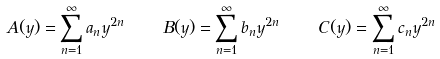<formula> <loc_0><loc_0><loc_500><loc_500>A ( y ) = \sum _ { n = 1 } ^ { \infty } a _ { n } y ^ { 2 n } \quad B ( y ) = \sum _ { n = 1 } ^ { \infty } b _ { n } y ^ { 2 n } \quad C ( y ) = \sum _ { n = 1 } ^ { \infty } c _ { n } y ^ { 2 n }</formula> 